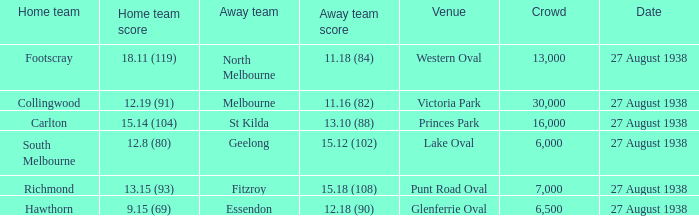What is the count of people who watched their home team reach a score of 13.15 (93)? 7000.0. 